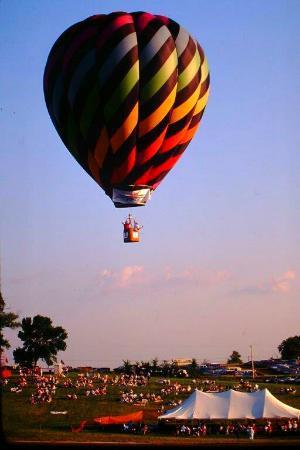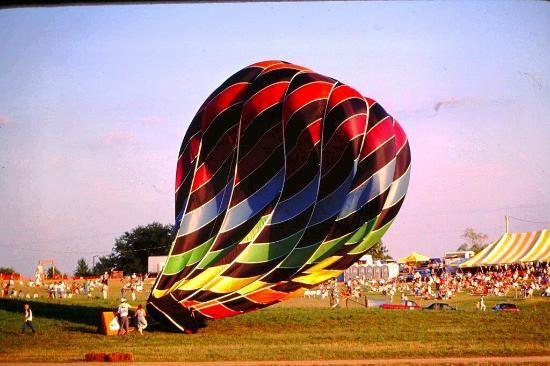The first image is the image on the left, the second image is the image on the right. For the images shown, is this caption "The left image features at least one but no more than two hot air balloons in the air a distance from the ground, and the right image includes a hot air balloon that is not in the air." true? Answer yes or no. Yes. The first image is the image on the left, the second image is the image on the right. Evaluate the accuracy of this statement regarding the images: "At least one hot air balloon has a character's face on it.". Is it true? Answer yes or no. No. 